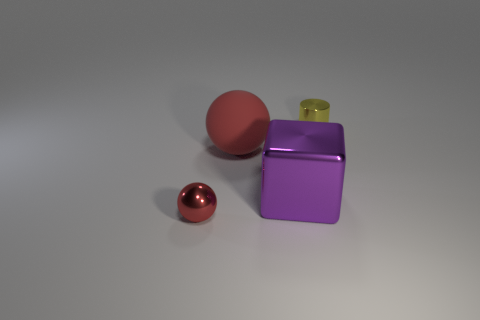There is a large sphere; does it have the same color as the thing that is on the left side of the large red ball?
Keep it short and to the point. Yes. How many other things are there of the same material as the small sphere?
Keep it short and to the point. 2. What is the shape of the red object that is the same material as the small cylinder?
Your answer should be compact. Sphere. Are there any other things that are the same color as the shiny cylinder?
Provide a succinct answer. No. There is a metal thing that is the same color as the matte sphere; what is its size?
Keep it short and to the point. Small. Is the number of yellow metallic cylinders that are in front of the purple object greater than the number of big red matte things?
Offer a terse response. No. Do the large matte thing and the shiny object that is behind the big red ball have the same shape?
Provide a succinct answer. No. What number of spheres are the same size as the red rubber object?
Give a very brief answer. 0. There is a metal object behind the red ball to the right of the small ball; how many purple metal cubes are behind it?
Provide a succinct answer. 0. Are there the same number of large purple things that are behind the large metal cube and small red metal spheres behind the tiny red metallic sphere?
Your answer should be very brief. Yes. 